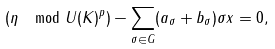Convert formula to latex. <formula><loc_0><loc_0><loc_500><loc_500>( \eta \mod U ( K ) ^ { p } ) - \sum _ { \sigma \in G } ( a _ { \sigma } + b _ { \sigma } ) \sigma x = 0 ,</formula> 